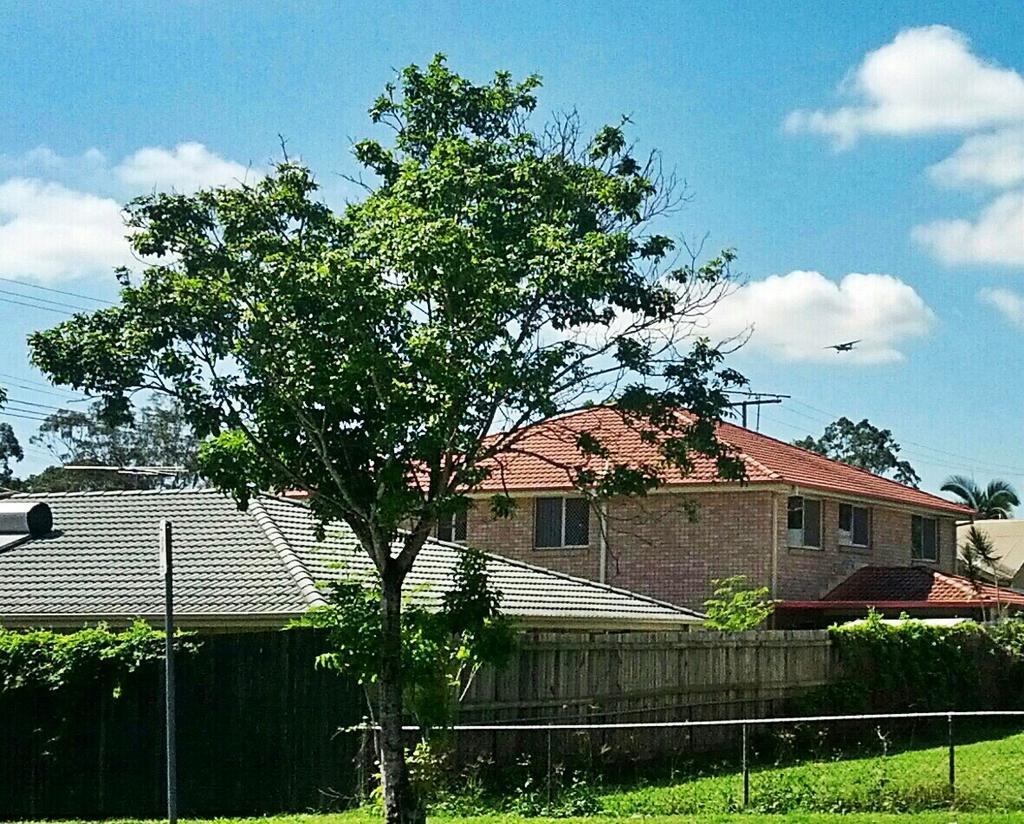Describe this image in one or two sentences. In this image, we can see some houses, trees, plants, poles, wires. We can see the ground with some grass. We can see the fence and the sky with clouds. 